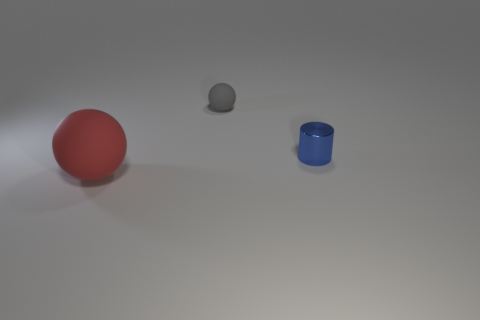Is there any other thing that has the same size as the red object?
Provide a succinct answer. No. There is a tiny object that is on the right side of the object behind the tiny blue object; what is its material?
Give a very brief answer. Metal. Is the number of tiny cylinders that are in front of the blue thing greater than the number of brown cylinders?
Ensure brevity in your answer.  No. Are there any tiny gray objects that have the same material as the blue cylinder?
Your response must be concise. No. There is a thing behind the small metallic thing; is it the same shape as the large thing?
Your response must be concise. Yes. There is a matte sphere that is on the right side of the rubber thing left of the small gray ball; what number of gray spheres are on the right side of it?
Offer a very short reply. 0. Are there fewer balls behind the small blue cylinder than blue metal things that are in front of the red sphere?
Offer a terse response. No. There is another small matte object that is the same shape as the red rubber object; what is its color?
Provide a succinct answer. Gray. What is the size of the blue metallic cylinder?
Offer a terse response. Small. What number of cylinders are the same size as the red ball?
Give a very brief answer. 0. 